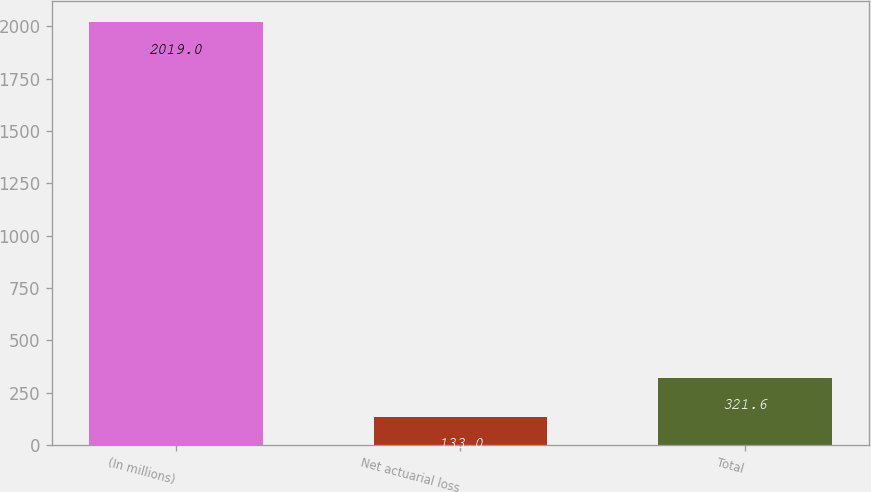Convert chart to OTSL. <chart><loc_0><loc_0><loc_500><loc_500><bar_chart><fcel>(In millions)<fcel>Net actuarial loss<fcel>Total<nl><fcel>2019<fcel>133<fcel>321.6<nl></chart> 